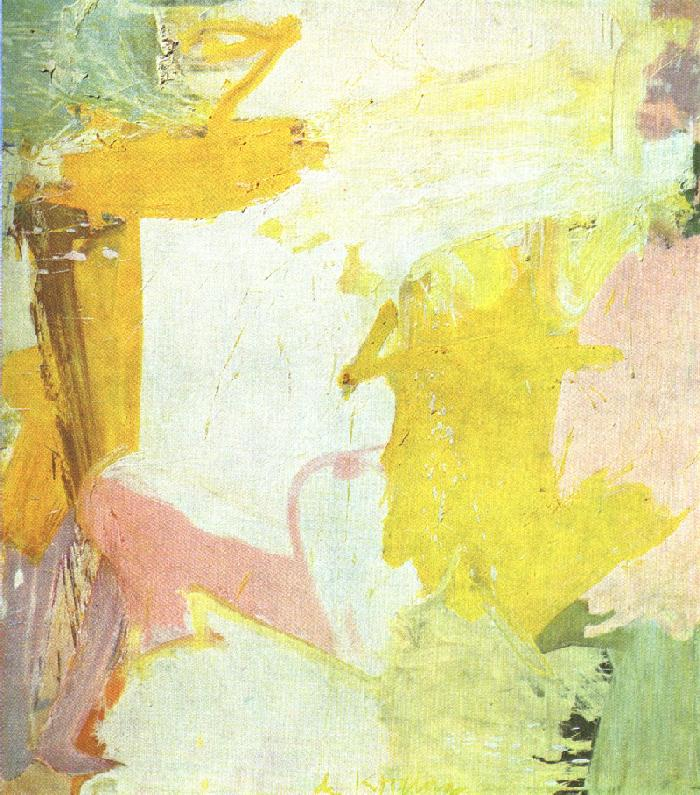How might one interpret the composition of this painting? The composition of this abstract painting is open to interpretation. One might see it as a non-linear narrative, a visual poem of sorts, that doesn't guide the observer in a specific direction but rather invites them to wander through the textures and forms at their own pace. The composition hints at spontaneity and improvisation, suggesting a sense of freedom and the absence of conventional boundaries. 